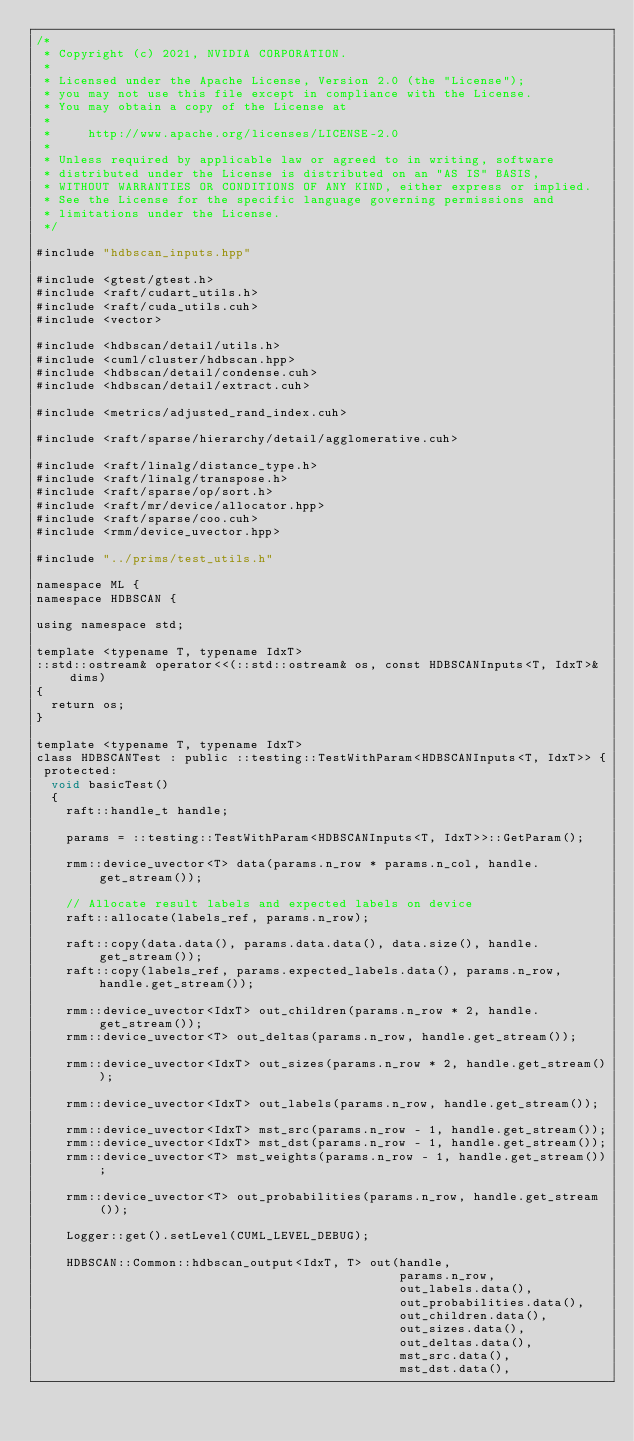Convert code to text. <code><loc_0><loc_0><loc_500><loc_500><_Cuda_>/*
 * Copyright (c) 2021, NVIDIA CORPORATION.
 *
 * Licensed under the Apache License, Version 2.0 (the "License");
 * you may not use this file except in compliance with the License.
 * You may obtain a copy of the License at
 *
 *     http://www.apache.org/licenses/LICENSE-2.0
 *
 * Unless required by applicable law or agreed to in writing, software
 * distributed under the License is distributed on an "AS IS" BASIS,
 * WITHOUT WARRANTIES OR CONDITIONS OF ANY KIND, either express or implied.
 * See the License for the specific language governing permissions and
 * limitations under the License.
 */

#include "hdbscan_inputs.hpp"

#include <gtest/gtest.h>
#include <raft/cudart_utils.h>
#include <raft/cuda_utils.cuh>
#include <vector>

#include <hdbscan/detail/utils.h>
#include <cuml/cluster/hdbscan.hpp>
#include <hdbscan/detail/condense.cuh>
#include <hdbscan/detail/extract.cuh>

#include <metrics/adjusted_rand_index.cuh>

#include <raft/sparse/hierarchy/detail/agglomerative.cuh>

#include <raft/linalg/distance_type.h>
#include <raft/linalg/transpose.h>
#include <raft/sparse/op/sort.h>
#include <raft/mr/device/allocator.hpp>
#include <raft/sparse/coo.cuh>
#include <rmm/device_uvector.hpp>

#include "../prims/test_utils.h"

namespace ML {
namespace HDBSCAN {

using namespace std;

template <typename T, typename IdxT>
::std::ostream& operator<<(::std::ostream& os, const HDBSCANInputs<T, IdxT>& dims)
{
  return os;
}

template <typename T, typename IdxT>
class HDBSCANTest : public ::testing::TestWithParam<HDBSCANInputs<T, IdxT>> {
 protected:
  void basicTest()
  {
    raft::handle_t handle;

    params = ::testing::TestWithParam<HDBSCANInputs<T, IdxT>>::GetParam();

    rmm::device_uvector<T> data(params.n_row * params.n_col, handle.get_stream());

    // Allocate result labels and expected labels on device
    raft::allocate(labels_ref, params.n_row);

    raft::copy(data.data(), params.data.data(), data.size(), handle.get_stream());
    raft::copy(labels_ref, params.expected_labels.data(), params.n_row, handle.get_stream());

    rmm::device_uvector<IdxT> out_children(params.n_row * 2, handle.get_stream());
    rmm::device_uvector<T> out_deltas(params.n_row, handle.get_stream());

    rmm::device_uvector<IdxT> out_sizes(params.n_row * 2, handle.get_stream());

    rmm::device_uvector<IdxT> out_labels(params.n_row, handle.get_stream());

    rmm::device_uvector<IdxT> mst_src(params.n_row - 1, handle.get_stream());
    rmm::device_uvector<IdxT> mst_dst(params.n_row - 1, handle.get_stream());
    rmm::device_uvector<T> mst_weights(params.n_row - 1, handle.get_stream());

    rmm::device_uvector<T> out_probabilities(params.n_row, handle.get_stream());

    Logger::get().setLevel(CUML_LEVEL_DEBUG);

    HDBSCAN::Common::hdbscan_output<IdxT, T> out(handle,
                                                 params.n_row,
                                                 out_labels.data(),
                                                 out_probabilities.data(),
                                                 out_children.data(),
                                                 out_sizes.data(),
                                                 out_deltas.data(),
                                                 mst_src.data(),
                                                 mst_dst.data(),</code> 